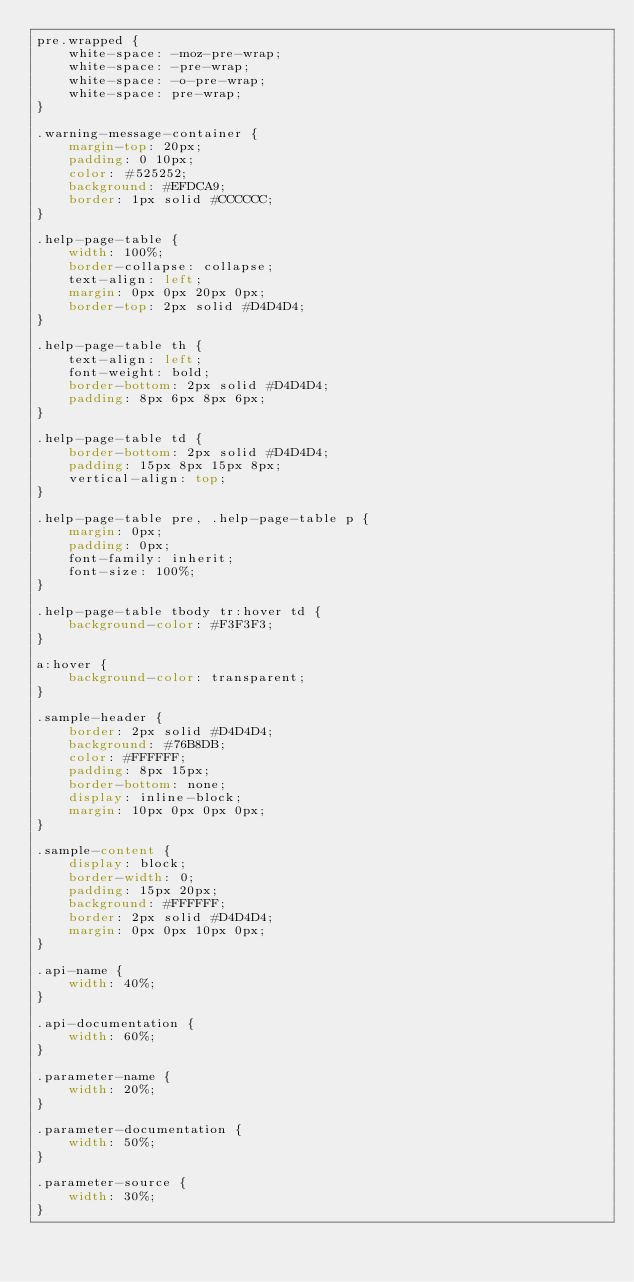Convert code to text. <code><loc_0><loc_0><loc_500><loc_500><_CSS_>pre.wrapped {
    white-space: -moz-pre-wrap;
    white-space: -pre-wrap;
    white-space: -o-pre-wrap;
    white-space: pre-wrap;
}

.warning-message-container {
    margin-top: 20px;
    padding: 0 10px;
    color: #525252;
    background: #EFDCA9;
    border: 1px solid #CCCCCC;
}

.help-page-table {
    width: 100%;
    border-collapse: collapse;
    text-align: left;
    margin: 0px 0px 20px 0px;
    border-top: 2px solid #D4D4D4;
}

.help-page-table th {
    text-align: left;
    font-weight: bold;
    border-bottom: 2px solid #D4D4D4;
    padding: 8px 6px 8px 6px;
}

.help-page-table td {
    border-bottom: 2px solid #D4D4D4;
    padding: 15px 8px 15px 8px;
    vertical-align: top;
}

.help-page-table pre, .help-page-table p {
    margin: 0px;
    padding: 0px;
    font-family: inherit;
    font-size: 100%;
}

.help-page-table tbody tr:hover td {
    background-color: #F3F3F3;
}

a:hover {
    background-color: transparent;
}

.sample-header {
    border: 2px solid #D4D4D4;
    background: #76B8DB;
    color: #FFFFFF;
    padding: 8px 15px;
    border-bottom: none;
    display: inline-block;
    margin: 10px 0px 0px 0px;
}

.sample-content {
    display: block;
    border-width: 0;
    padding: 15px 20px;
    background: #FFFFFF;
    border: 2px solid #D4D4D4;
    margin: 0px 0px 10px 0px;
}

.api-name {
    width: 40%;
}

.api-documentation {
    width: 60%;
}

.parameter-name {
    width: 20%;
}

.parameter-documentation {
    width: 50%;
}

.parameter-source {
    width: 30%;
}</code> 